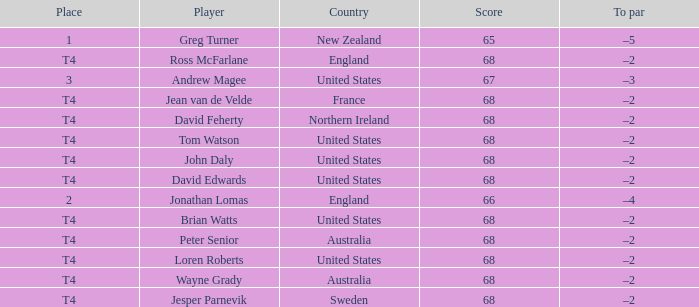Who has a To par of –2, and a Country of united states? John Daly, David Edwards, Loren Roberts, Tom Watson, Brian Watts. 